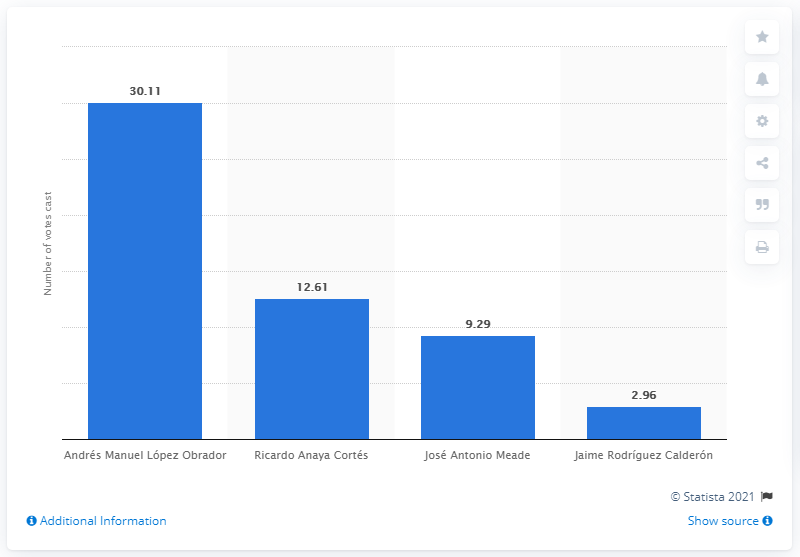Could you explain why there might be a source link included in this image? The source link included on the image usually leads to the original data or the place where further detailed information can be found. It's a way to credit the data provider and allows users to verify the information or explore more in-depth statistics related to the election results presented in the chart. 